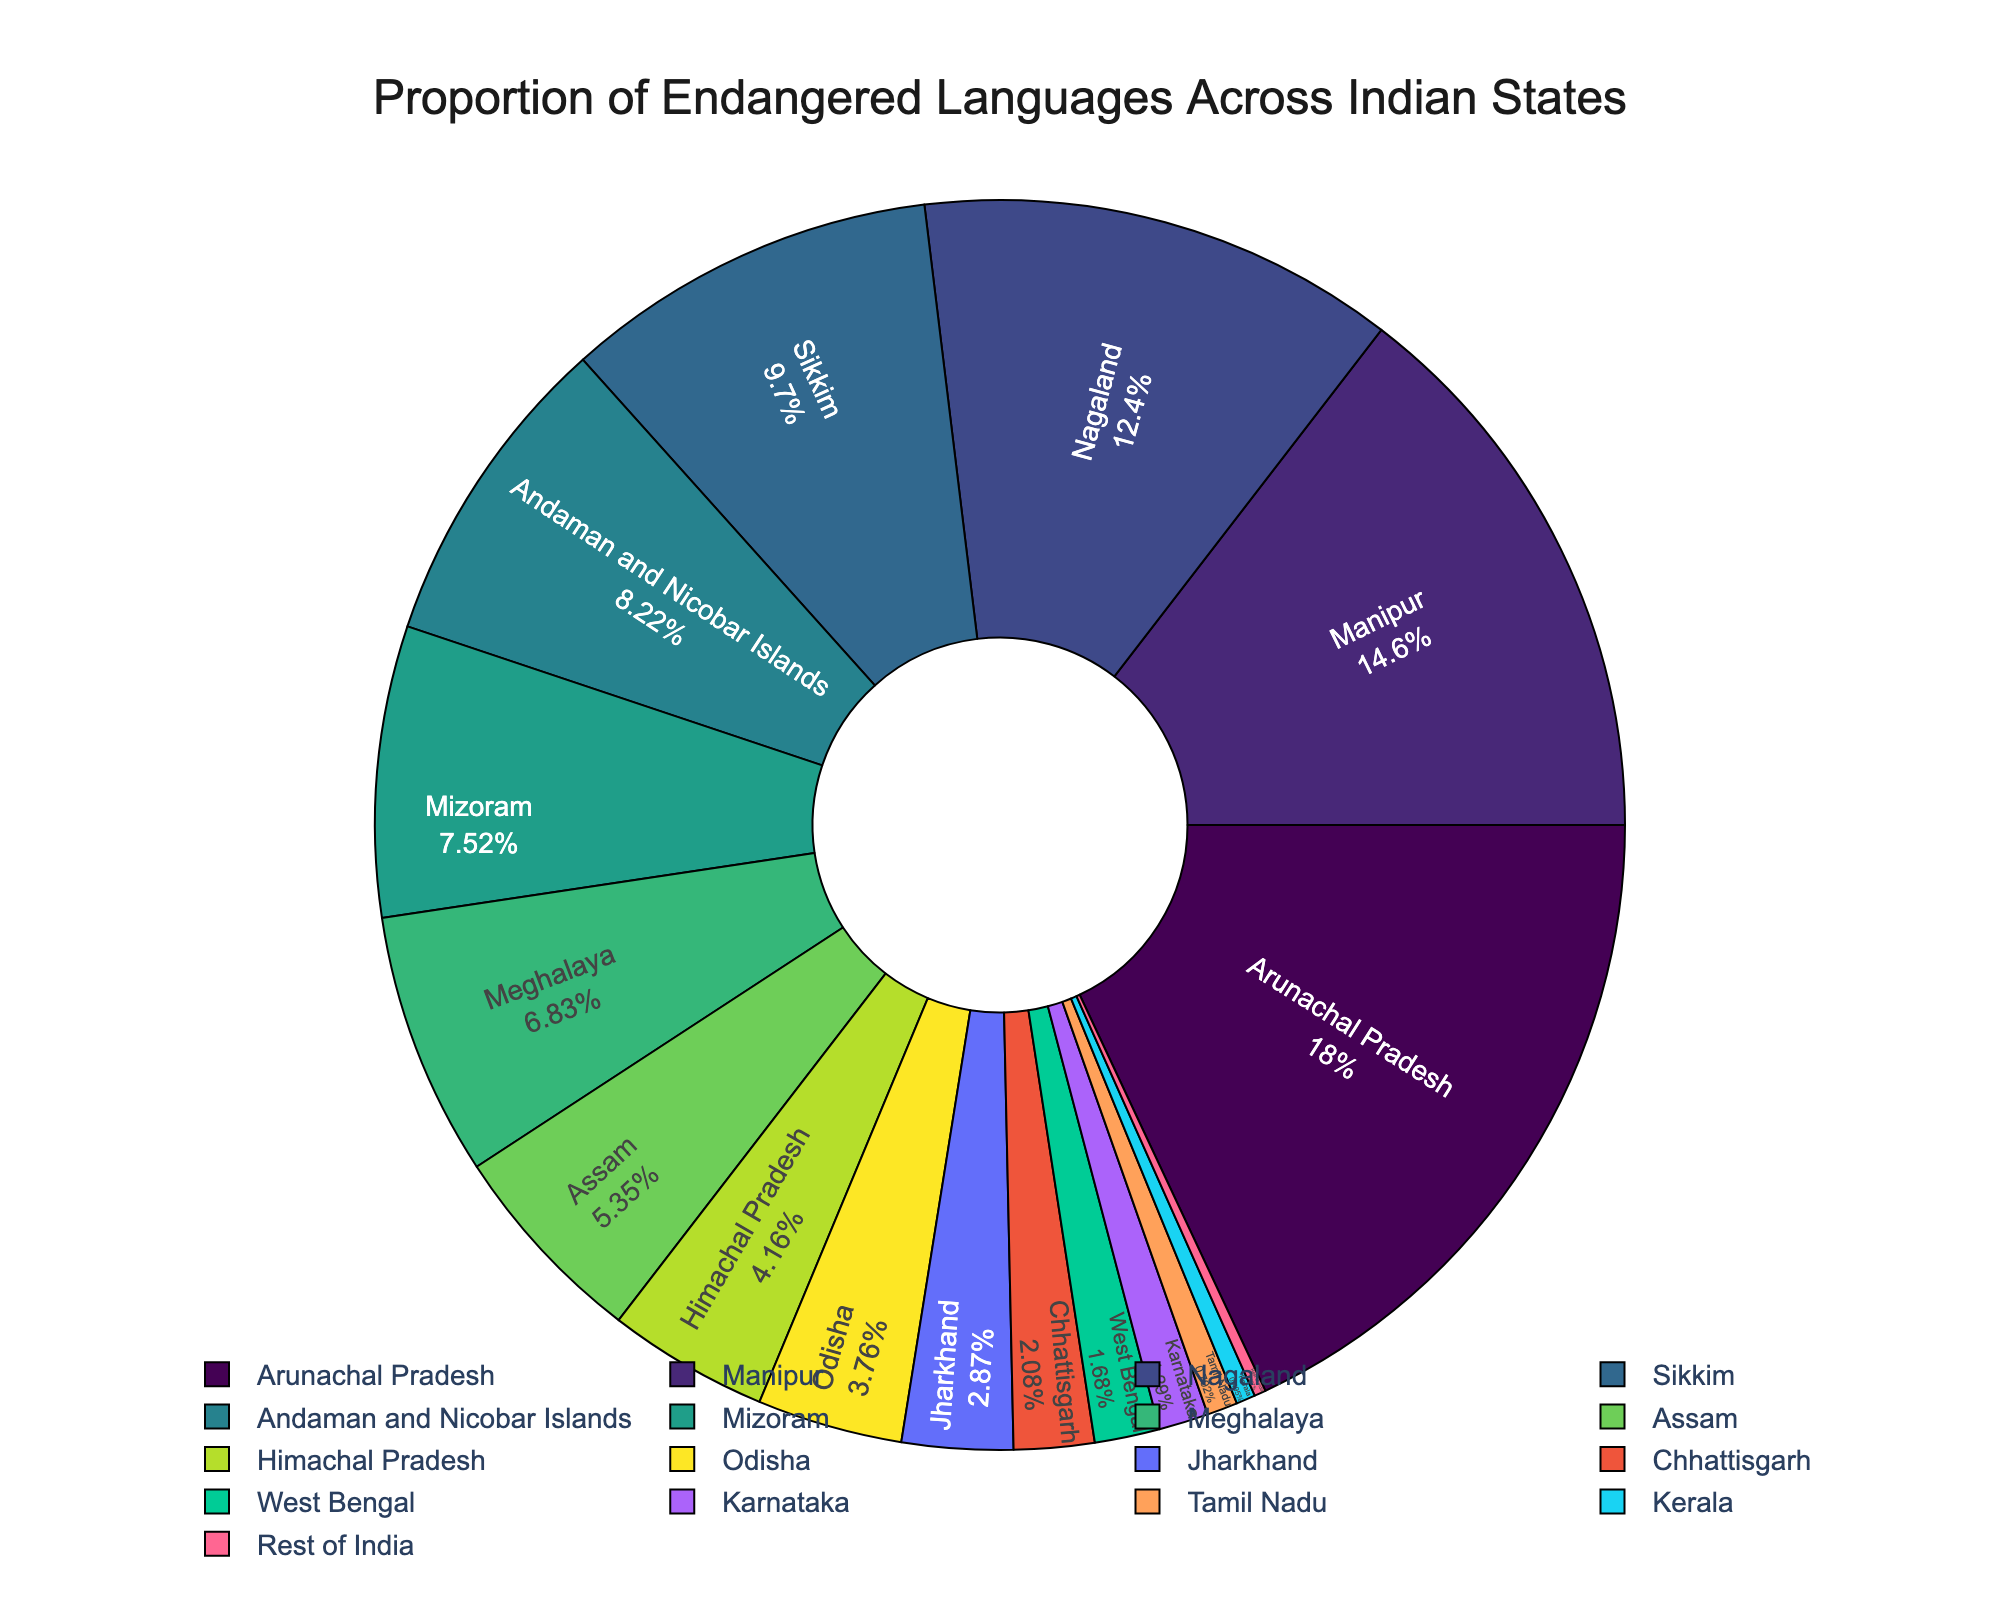What is the state with the highest proportion of endangered languages? The state with the highest proportion will have the largest slice in the pie chart. Arunachal Pradesh has the largest slice.
Answer: Arunachal Pradesh Which states have a higher proportion of endangered languages than Meghalaya? Compare the slices of Meghalaya with other states. Arunachal Pradesh, Manipur, Nagaland, Sikkim, Andaman and Nicobar Islands, and Mizoram all have larger slices than Meghalaya.
Answer: Arunachal Pradesh, Manipur, Nagaland, Sikkim, Andaman and Nicobar Islands, Mizoram Which state has a slightly lower proportion than Manipur? Manipur's proportion is 14.7%. Look for the slice just smaller than that. Nagaland is next with 12.5%.
Answer: Nagaland How much larger is the proportion of endangered languages in Nagaland compared to Tamil Nadu? The proportion for Nagaland is 12.5%, and for Tamil Nadu, it is 0.8%. Subtract the two percentages: 12.5% - 0.8% = 11.7%.
Answer: 11.7% What is the combined proportion of Manipur and Mizoram? Add the percentages of Manipur and Mizoram. 14.7% + 7.6% = 22.3%.
Answer: 22.3% Which state falls right in the middle when listing the states by proportion of endangered languages from highest to lowest? List states in descending order of proportions and find the middle one. The middle state, with 5.4%, is Assam.
Answer: Assam What is the difference in proportion between the state with the highest and the state with the lowest proportion of endangered languages? Arunachal Pradesh has the highest at 18.2% and the "Rest of India" has the lowest at 0.3%. Subtract 0.3% from 18.2%, which is 17.9%.
Answer: 17.9% How does the proportion of endangered languages in Odisha compare to Jharkhand? Compare the slices corresponding to Odisha (3.8%) and Jharkhand (2.9%). Odisha has a higher proportion.
Answer: Odisha Which states have a proportion of endangered languages less than 2%? Look at the slices smaller than 2%: West Bengal (1.7%), Karnataka (1.3%), Tamil Nadu (0.8%), Kerala (0.5%), Rest of India (0.3%).
Answer: West Bengal, Karnataka, Tamil Nadu, Kerala, Rest of India What is the total proportion of endangered languages in Arunachal Pradesh, Manipur, and Nagaland combined? Add the percentages of Arunachal Pradesh, Manipur, and Nagaland. 18.2% + 14.7% + 12.5% = 45.4%.
Answer: 45.4% 